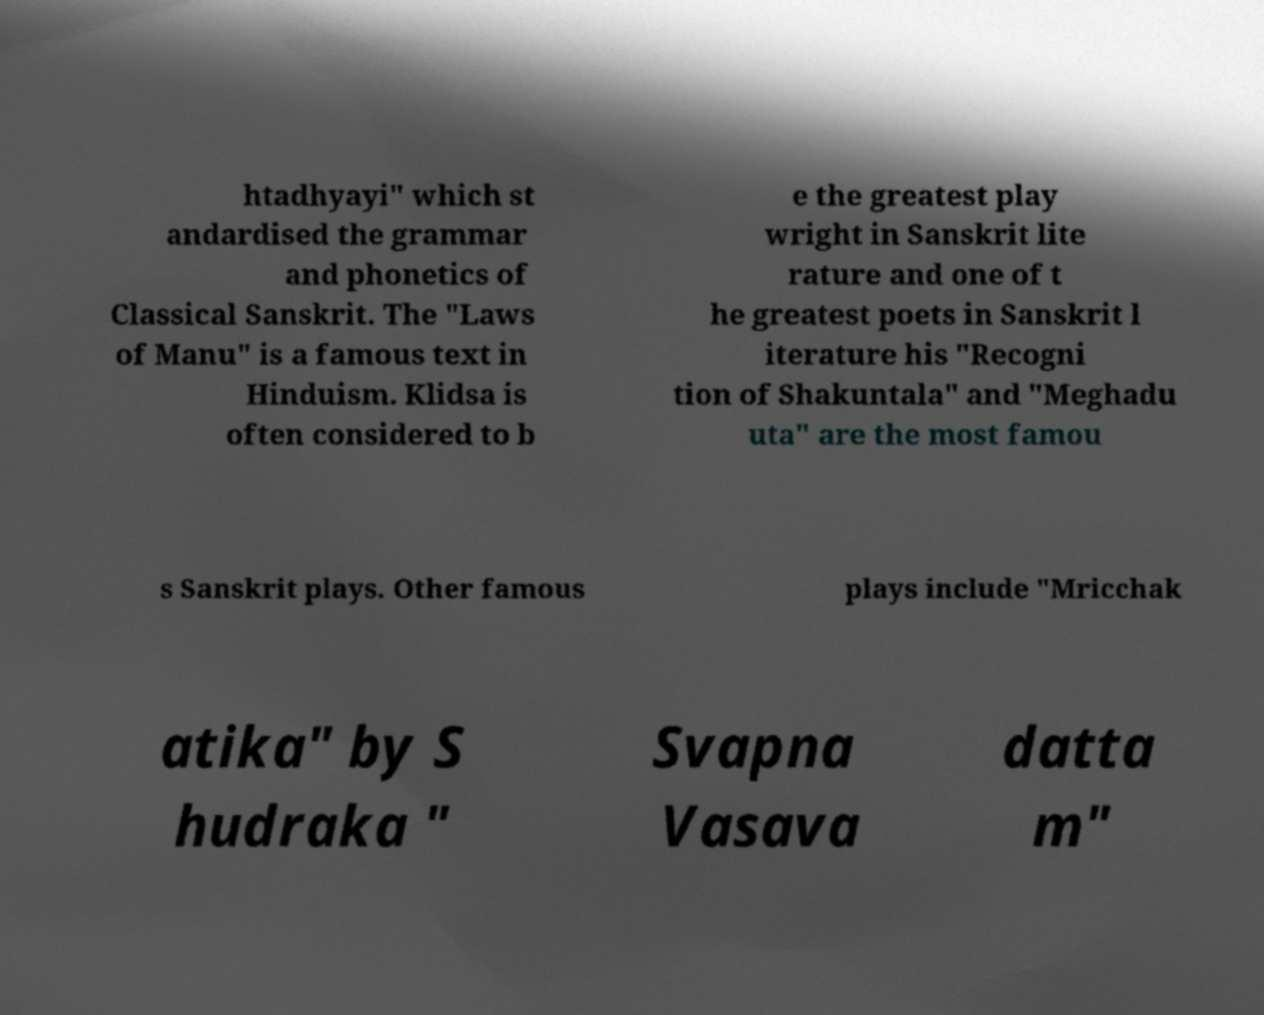I need the written content from this picture converted into text. Can you do that? htadhyayi" which st andardised the grammar and phonetics of Classical Sanskrit. The "Laws of Manu" is a famous text in Hinduism. Klidsa is often considered to b e the greatest play wright in Sanskrit lite rature and one of t he greatest poets in Sanskrit l iterature his "Recogni tion of Shakuntala" and "Meghadu uta" are the most famou s Sanskrit plays. Other famous plays include "Mricchak atika" by S hudraka " Svapna Vasava datta m" 